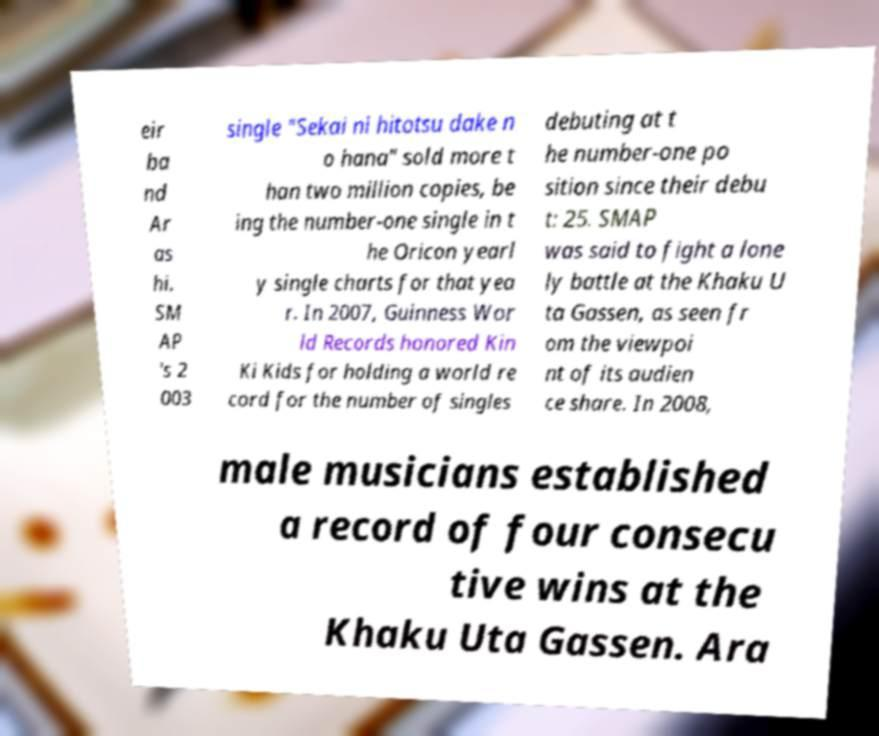There's text embedded in this image that I need extracted. Can you transcribe it verbatim? eir ba nd Ar as hi. SM AP 's 2 003 single "Sekai ni hitotsu dake n o hana" sold more t han two million copies, be ing the number-one single in t he Oricon yearl y single charts for that yea r. In 2007, Guinness Wor ld Records honored Kin Ki Kids for holding a world re cord for the number of singles debuting at t he number-one po sition since their debu t: 25. SMAP was said to fight a lone ly battle at the Khaku U ta Gassen, as seen fr om the viewpoi nt of its audien ce share. In 2008, male musicians established a record of four consecu tive wins at the Khaku Uta Gassen. Ara 